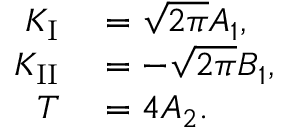Convert formula to latex. <formula><loc_0><loc_0><loc_500><loc_500>\begin{array} { r l } { K _ { I } } & = \sqrt { 2 \pi } A _ { 1 } , } \\ { K _ { I I } } & = - \sqrt { 2 \pi } B _ { 1 } , } \\ { T } & = 4 A _ { 2 } . } \end{array}</formula> 